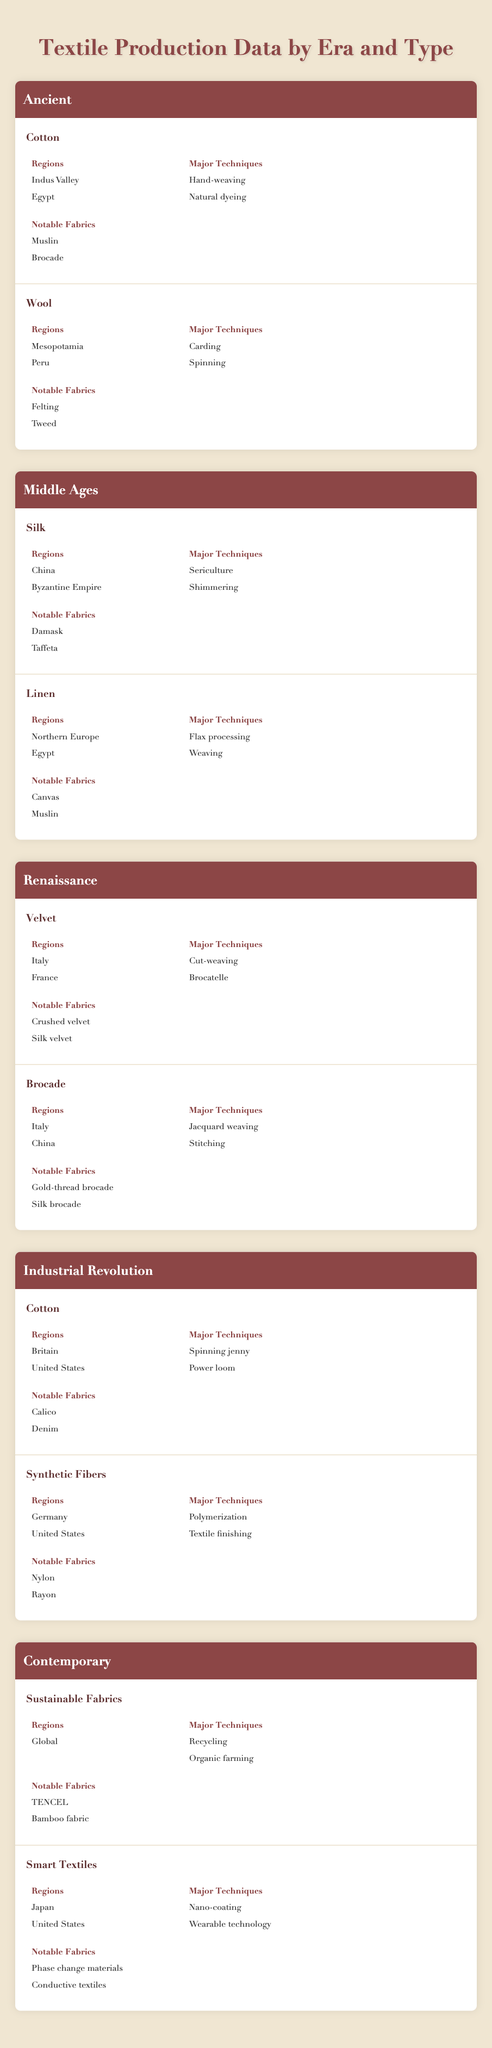What regions were associated with the production of Cotton in the Ancient era? The table indicates that Cotton was produced in the Indus Valley and Egypt during the Ancient era. Both regions are listed under the "Regions" section for Cotton in the Ancient category.
Answer: Indus Valley, Egypt What are the notable fabrics made from Wool in the Ancient era? According to the table, the notable fabrics made from Wool during the Ancient era are Felting and Tweed. These fabrics are specifically mentioned under the "Notable Fabrics" section for Wool in the Ancient category.
Answer: Felting, Tweed Which major techniques were used for fabric production in the Middle Ages? The table contains the major techniques for two types of fabrics in the Middle Ages: Silk and Linen. The techniques are Sericulture and Shimmering for Silk, and Flax processing and Weaving for Linen. These can be combined to summarize the techniques for the period.
Answer: Sericulture, Shimmering, Flax processing, Weaving Did the Renaissance era feature the production of Velvet? Yes, the table confirms that Velvet was produced during the Renaissance era, as it is explicitly listed as one of the textile types under the Renaissance category.
Answer: Yes Which periods featured Cotton as a textile type? The table shows that Cotton was featured in both the Ancient era and the Industrial Revolution. In the Ancient era, it was produced with techniques like Hand-weaving and Natural dyeing, and in the Industrial Revolution, techniques included the Spinning jenny and Power loom.
Answer: Ancient, Industrial Revolution What is the relationship between regions and notable fabrics for Brocade in the Renaissance era? The table lists Italy and China as the regions for Brocade, while the notable fabrics associated with it are Gold-thread brocade and Silk brocade. Thus, Brocade production is linked with these regions and notable fabrics in the Renaissance era.
Answer: Italy, China; Gold-thread brocade, Silk brocade How many notable fabrics were associated with Sustainable Fabrics in the Contemporary era? The Contemporary era confirms that Sustainable Fabrics include TENCEL and Bamboo fabric as notable fabrics. Summing them gives a total of 2 notable fabrics associated with Sustainable Fabrics.
Answer: 2 In which regions were Smart Textiles produced, and what major techniques were utilized? The table states that Smart Textiles were produced in Japan and the United States, utilizing major techniques like Nano-coating and Wearable technology. This information is derived from both the "Regions" and "Major Techniques" sections of Smart Textiles.
Answer: Japan, United States; Nano-coating, Wearable technology What were the notable fabrics resulting from the Industrial Revolution's Synthetic Fibers? The table specifies that Synthetic Fibers produced notable fabrics like Nylon and Rayon during the Industrial Revolution. These are listed under the "Notable Fabrics" heading for Synthetic Fibers in the Industrial Revolution category.
Answer: Nylon, Rayon 